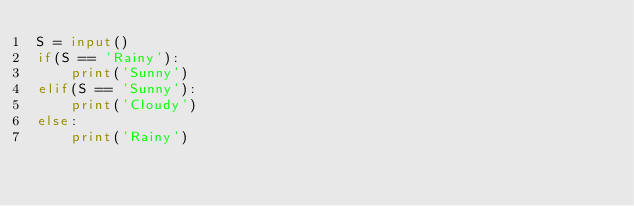<code> <loc_0><loc_0><loc_500><loc_500><_Python_>S = input()
if(S == 'Rainy'):
    print('Sunny')
elif(S == 'Sunny'):
    print('Cloudy')
else:
    print('Rainy')</code> 